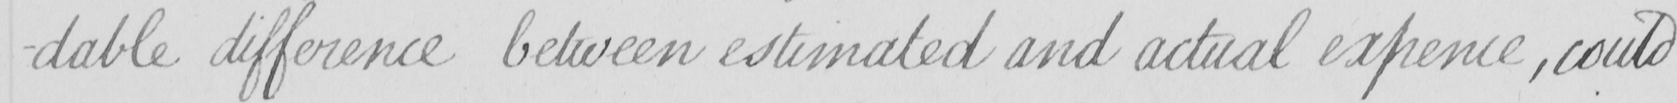What does this handwritten line say? -dable difference between estimated and actual expence  , could 